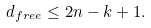Convert formula to latex. <formula><loc_0><loc_0><loc_500><loc_500>d _ { f r e e } \leq 2 n - k + 1 .</formula> 